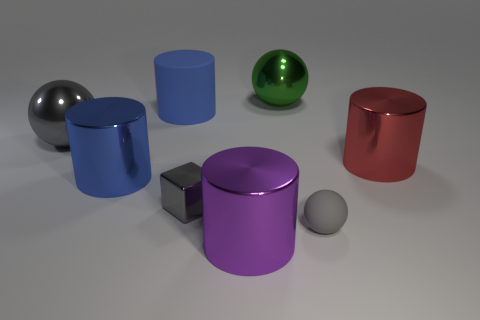Subtract all shiny spheres. How many spheres are left? 1 Add 2 large red cylinders. How many objects exist? 10 Subtract 2 spheres. How many spheres are left? 1 Subtract all gray blocks. How many gray spheres are left? 2 Subtract all purple cylinders. How many cylinders are left? 3 Subtract all cubes. How many objects are left? 7 Subtract all brown balls. Subtract all purple blocks. How many balls are left? 3 Subtract all large purple objects. Subtract all tiny gray balls. How many objects are left? 6 Add 2 tiny rubber things. How many tiny rubber things are left? 3 Add 7 spheres. How many spheres exist? 10 